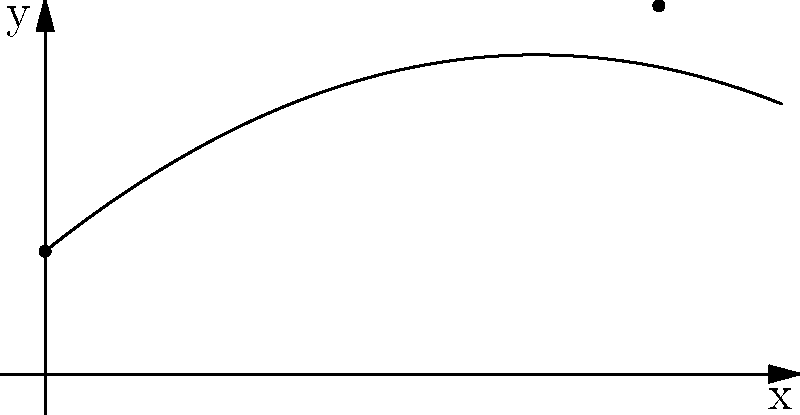In a side-scrolling game, a projectile's trajectory is modeled by the polynomial function $f(x) = -0.05x^2 + 0.8x + 2$, where $x$ represents the horizontal distance and $f(x)$ represents the vertical height (both in game units). At what horizontal distance will the projectile reach its maximum height? To find the maximum height of the projectile, we need to determine the vertex of the parabola. For a quadratic function in the form $f(x) = ax^2 + bx + c$, the x-coordinate of the vertex is given by $x = -\frac{b}{2a}$.

1. Identify the coefficients:
   $a = -0.05$
   $b = 0.8$
   $c = 2$

2. Apply the formula:
   $x = -\frac{b}{2a} = -\frac{0.8}{2(-0.05)} = -\frac{0.8}{-0.1} = 8$

3. Verify:
   The parabola opens downward (because $a$ is negative), so this x-value corresponds to the maximum point.

Therefore, the projectile will reach its maximum height at a horizontal distance of 8 game units.
Answer: 8 game units 